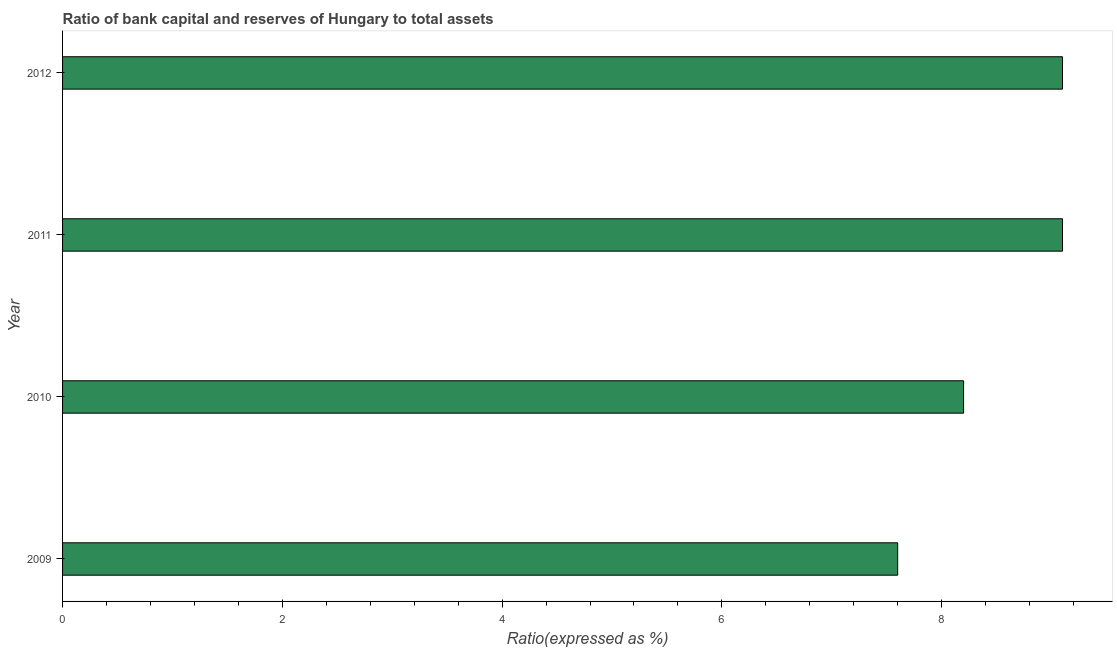What is the title of the graph?
Give a very brief answer. Ratio of bank capital and reserves of Hungary to total assets. What is the label or title of the X-axis?
Your response must be concise. Ratio(expressed as %). Across all years, what is the minimum bank capital to assets ratio?
Offer a terse response. 7.6. In which year was the bank capital to assets ratio maximum?
Your answer should be very brief. 2011. In which year was the bank capital to assets ratio minimum?
Give a very brief answer. 2009. What is the sum of the bank capital to assets ratio?
Ensure brevity in your answer.  34. What is the average bank capital to assets ratio per year?
Give a very brief answer. 8.5. What is the median bank capital to assets ratio?
Your answer should be very brief. 8.65. Do a majority of the years between 2011 and 2012 (inclusive) have bank capital to assets ratio greater than 3.2 %?
Your response must be concise. Yes. What is the ratio of the bank capital to assets ratio in 2009 to that in 2011?
Provide a short and direct response. 0.83. Is the bank capital to assets ratio in 2009 less than that in 2011?
Ensure brevity in your answer.  Yes. Is the sum of the bank capital to assets ratio in 2009 and 2012 greater than the maximum bank capital to assets ratio across all years?
Provide a succinct answer. Yes. In how many years, is the bank capital to assets ratio greater than the average bank capital to assets ratio taken over all years?
Keep it short and to the point. 2. How many years are there in the graph?
Your response must be concise. 4. Are the values on the major ticks of X-axis written in scientific E-notation?
Keep it short and to the point. No. What is the Ratio(expressed as %) of 2010?
Your answer should be compact. 8.2. What is the Ratio(expressed as %) of 2011?
Your response must be concise. 9.1. What is the Ratio(expressed as %) of 2012?
Give a very brief answer. 9.1. What is the difference between the Ratio(expressed as %) in 2009 and 2011?
Keep it short and to the point. -1.5. What is the difference between the Ratio(expressed as %) in 2010 and 2011?
Your response must be concise. -0.9. What is the difference between the Ratio(expressed as %) in 2010 and 2012?
Keep it short and to the point. -0.9. What is the difference between the Ratio(expressed as %) in 2011 and 2012?
Keep it short and to the point. 0. What is the ratio of the Ratio(expressed as %) in 2009 to that in 2010?
Give a very brief answer. 0.93. What is the ratio of the Ratio(expressed as %) in 2009 to that in 2011?
Your answer should be very brief. 0.83. What is the ratio of the Ratio(expressed as %) in 2009 to that in 2012?
Make the answer very short. 0.83. What is the ratio of the Ratio(expressed as %) in 2010 to that in 2011?
Your response must be concise. 0.9. What is the ratio of the Ratio(expressed as %) in 2010 to that in 2012?
Provide a short and direct response. 0.9. 